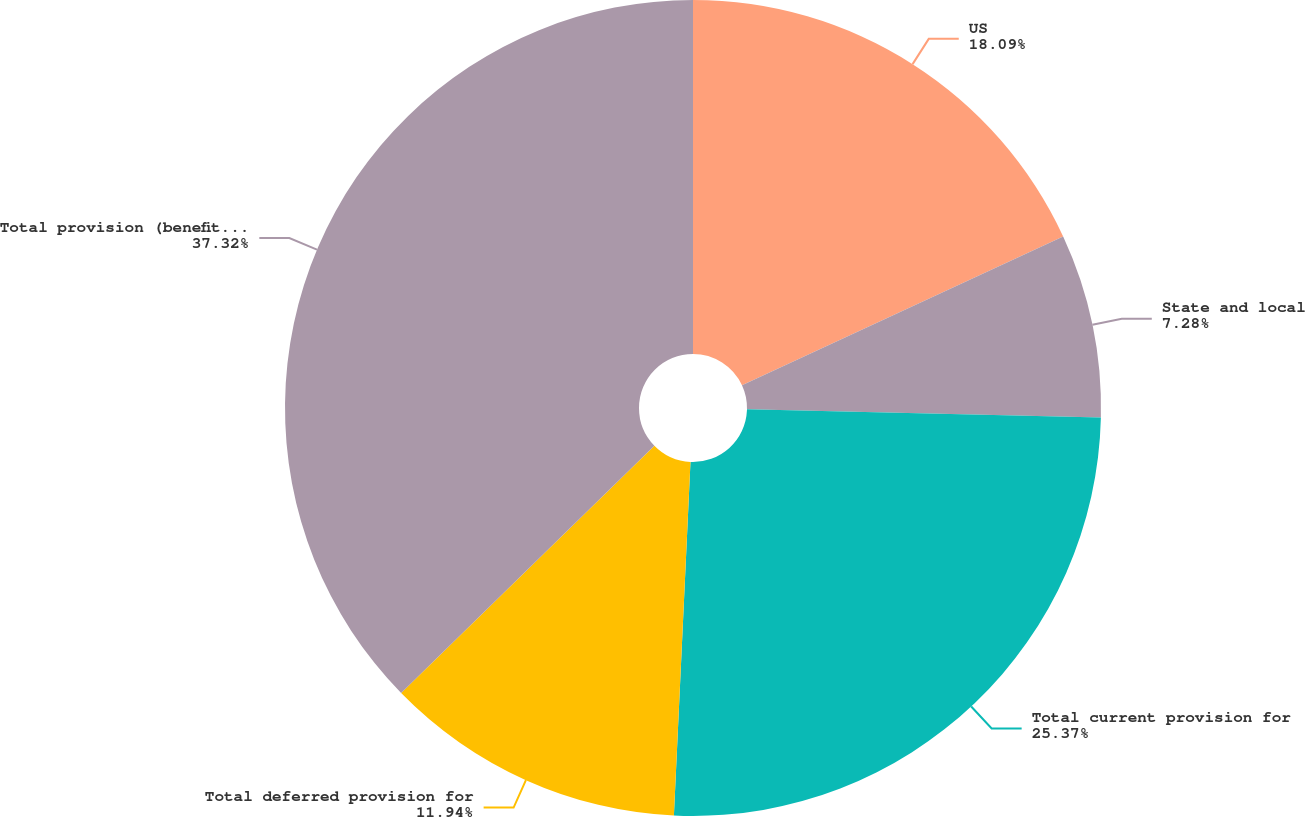<chart> <loc_0><loc_0><loc_500><loc_500><pie_chart><fcel>US<fcel>State and local<fcel>Total current provision for<fcel>Total deferred provision for<fcel>Total provision (benefit) for<nl><fcel>18.09%<fcel>7.28%<fcel>25.37%<fcel>11.94%<fcel>37.31%<nl></chart> 